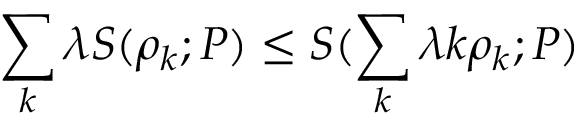Convert formula to latex. <formula><loc_0><loc_0><loc_500><loc_500>\sum _ { k } \lambda S ( \rho _ { k } ; P ) \leq S ( \sum _ { k } \lambda k \rho _ { k } ; P )</formula> 